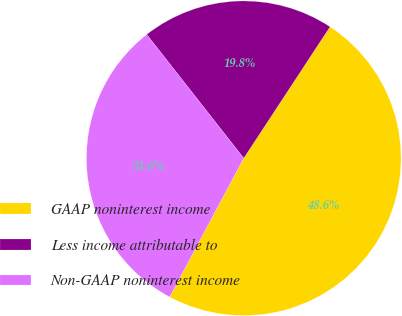<chart> <loc_0><loc_0><loc_500><loc_500><pie_chart><fcel>GAAP noninterest income<fcel>Less income attributable to<fcel>Non-GAAP noninterest income<nl><fcel>48.56%<fcel>19.83%<fcel>31.61%<nl></chart> 